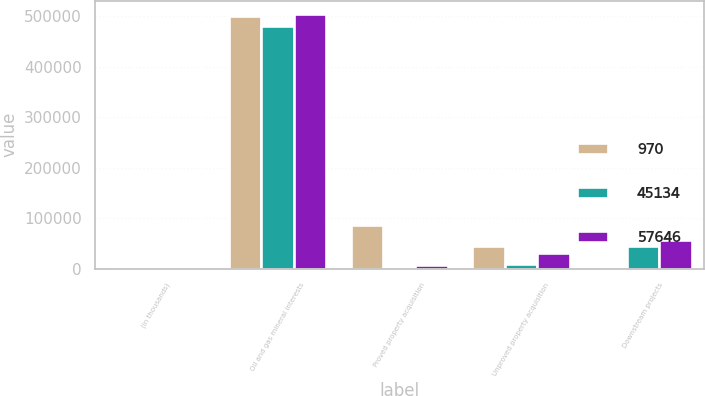Convert chart to OTSL. <chart><loc_0><loc_0><loc_500><loc_500><stacked_bar_chart><ecel><fcel>(in thousands)<fcel>Oil and gas mineral interests<fcel>Proved property acquisition<fcel>Unproved property acquisition<fcel>Downstream projects<nl><fcel>970<fcel>2004<fcel>501119<fcel>85785<fcel>44681<fcel>970<nl><fcel>45134<fcel>2003<fcel>481236<fcel>1294<fcel>10234<fcel>45134<nl><fcel>57646<fcel>2002<fcel>505464<fcel>7988<fcel>30515<fcel>57646<nl></chart> 